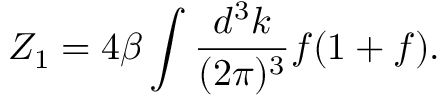<formula> <loc_0><loc_0><loc_500><loc_500>Z _ { 1 } = 4 \beta \int { \frac { d ^ { 3 } k } { ( 2 \pi ) ^ { 3 } } } f ( 1 + f ) .</formula> 